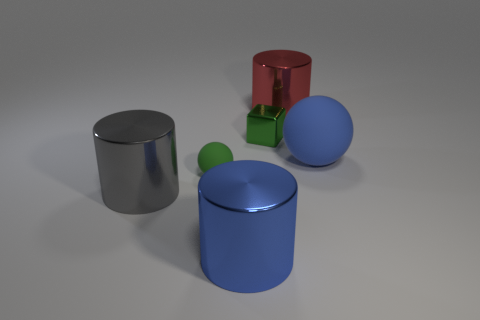Is the material of the large cylinder behind the tiny metallic thing the same as the sphere right of the red metallic cylinder?
Provide a succinct answer. No. The big cylinder on the right side of the blue thing that is in front of the rubber thing on the right side of the red cylinder is what color?
Your answer should be compact. Red. How many other things are there of the same shape as the small green matte thing?
Keep it short and to the point. 1. Do the small ball and the tiny block have the same color?
Provide a succinct answer. Yes. What number of objects are either blue things or large cylinders behind the gray cylinder?
Provide a short and direct response. 3. Are there any green metallic things that have the same size as the gray metallic thing?
Provide a succinct answer. No. Are the big gray thing and the large blue cylinder made of the same material?
Your response must be concise. Yes. How many objects are either blue balls or small things?
Provide a succinct answer. 3. How big is the blue metal cylinder?
Your response must be concise. Large. Are there fewer large red metal objects than green objects?
Provide a short and direct response. Yes. 